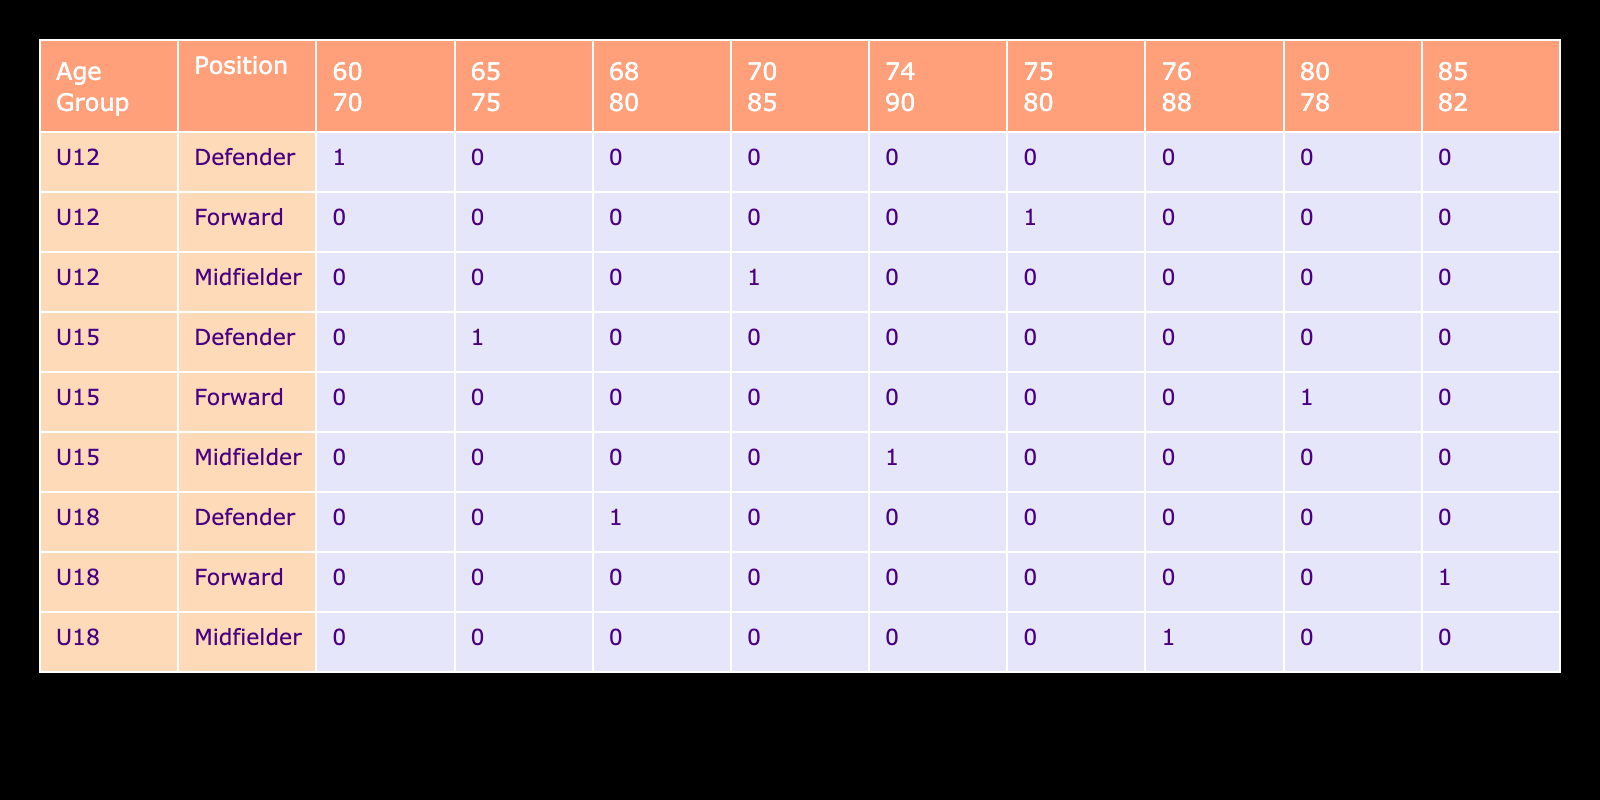What is the highest number of goals scored by players in the U15 age group? The U15 data shows that the Forward position scored 15 goals, more than any other position in that age group. The Midfielder scored 10, and the Defender scored 3. Therefore, the highest number of goals scored in the U15 age group is 15.
Answer: 15 Which position in the U12 age group has the lowest passing accuracy? Looking at the U12 age group, the Forward has a passing accuracy of 80, the Midfielder has 85, and the Defender has 70. The Defender has the lowest passing accuracy of 70.
Answer: 70 What is the average dribbling skill of players across all age groups? To get the average dribbling skill, we sum all the values: 75 (U12 Forward) + 70 (U12 Midfielder) + 60 (U12 Defender) + 80 (U15 Forward) + 74 (U15 Midfielder) + 65 (U15 Defender) + 85 (U18 Forward) + 76 (U18 Midfielder) + 68 (U18 Defender) =  75 + 70 + 60 + 80 + 74 + 65 + 85 + 76 + 68 =  79. The average is 79/9 ≈ 75.
Answer: 75 Are there any players in the U18 age group who scored more than 15 goals? In the U18 category, the Forward scored 20 goals, which is the only result above 15. Therefore, the statement is true.
Answer: Yes Which age group has the highest average for defensive awareness? To determine this, we calculate the average defensive awareness per age group:  (50 + 60 + 80)/3 for U12 = 63.33, (55 + 65 + 85)/3 for U15 = 68.33, and (60 + 70 + 90)/3 for U18 = 73.33. The U18 age group has the highest average defensive awareness of 73.33.
Answer: U18 